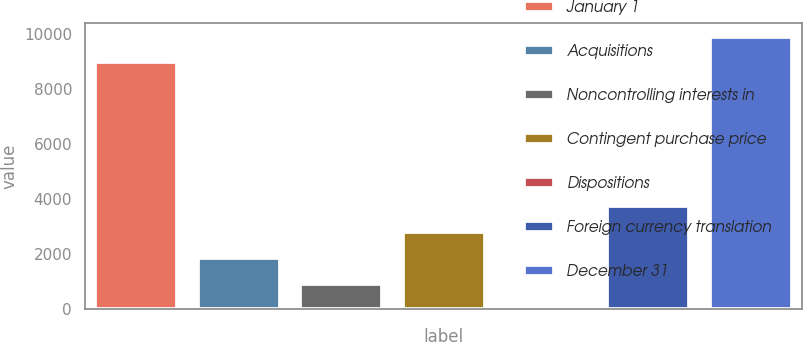Convert chart to OTSL. <chart><loc_0><loc_0><loc_500><loc_500><bar_chart><fcel>January 1<fcel>Acquisitions<fcel>Noncontrolling interests in<fcel>Contingent purchase price<fcel>Dispositions<fcel>Foreign currency translation<fcel>December 31<nl><fcel>8976.1<fcel>1871.18<fcel>937.89<fcel>2804.47<fcel>4.6<fcel>3737.76<fcel>9909.39<nl></chart> 